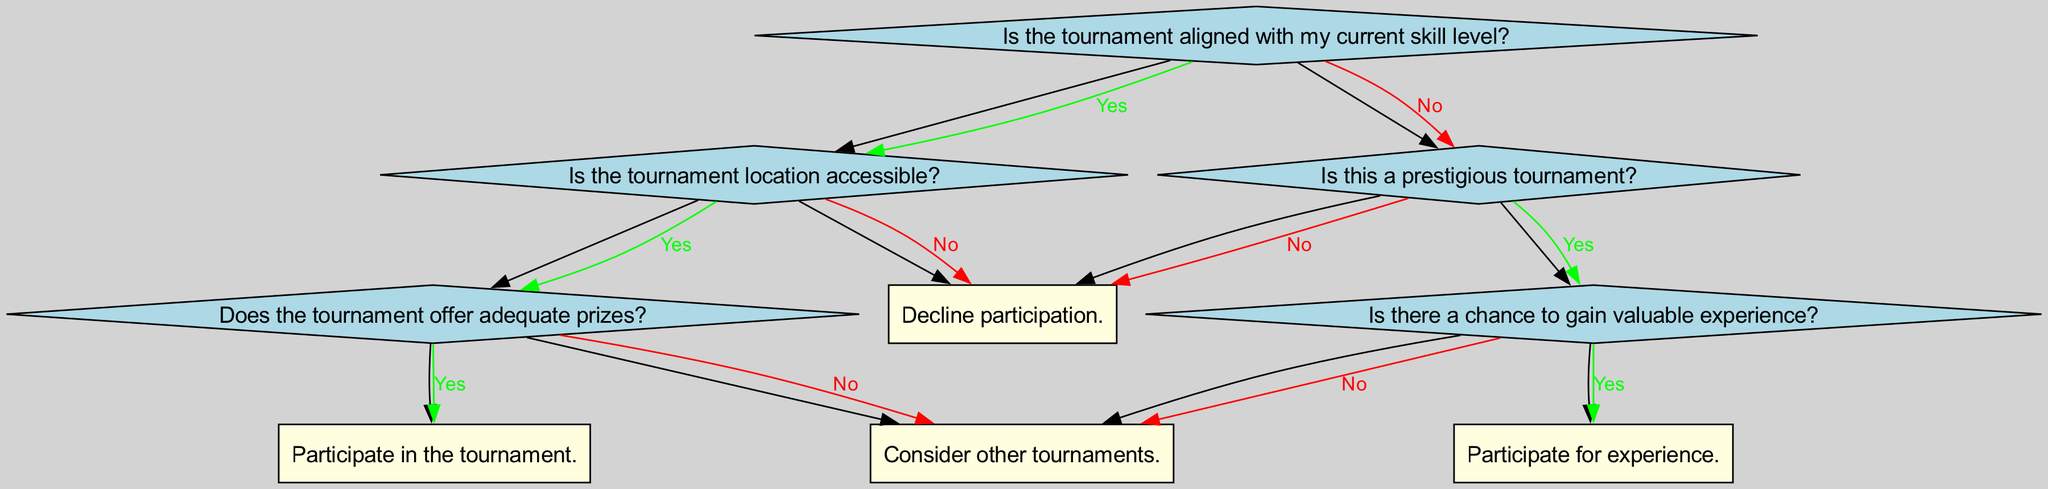What is the root question of the decision tree? The root question is "Is the tournament aligned with my current skill level?" This is the first question that guides the decision-making process in the tree.
Answer: Is the tournament aligned with my current skill level? How many decisions are made in the "Yes" branch? In the "Yes" branch, there are two decisions made: one about the tournament location being accessible and the second about the adequacy of the prizes.
Answer: Two decisions What happens if the tournament location is not accessible? If the tournament location is not accessible, the decision is to "Decline participation." This outcome follows directly from the response to the relevant question in the diagram.
Answer: Decline participation What is the final decision if the tournament is not aligned with the skill level and is prestigious? If the tournament is not aligned with the skill level but is prestigious, the next question is about gaining valuable experience. If the answer is yes, the final decision is to "Participate for experience."
Answer: Participate for experience How many edges connect the root node to the first set of nodes? There are two edges that connect the root node to the first set of nodes, which represent the "Yes" and "No" responses to the root question. This shows the two possible paths based on the initial question.
Answer: Two edges What is the decision if the tournament does not offer adequate prizes? If the tournament does not offer adequate prizes, the decision is to "Consider other tournaments." This follows from the response to the relevant question regarding prizes.
Answer: Consider other tournaments How does the decision tree guide participation in a tournament if it is not prestigious? If the tournament is not prestigious, the next step is to decline participation. This outcome is straightforward as indicated by the branching logic in the decision tree.
Answer: Decline participation What would be the outcome if the tournament is aligned with the skill level but does not offer adequate prizes? In this case, the decision would be to "Consider other tournaments." This happens after assessing the prize adequacy in the "Yes" path for skill level alignment.
Answer: Consider other tournaments 